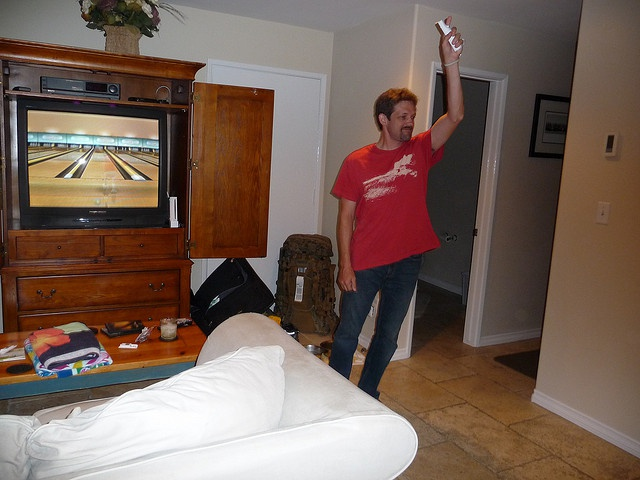Describe the objects in this image and their specific colors. I can see couch in gray, white, darkgray, and lightgray tones, people in gray, black, brown, and maroon tones, tv in gray, black, and tan tones, backpack in gray, black, and darkgray tones, and suitcase in gray, black, maroon, and darkgray tones in this image. 